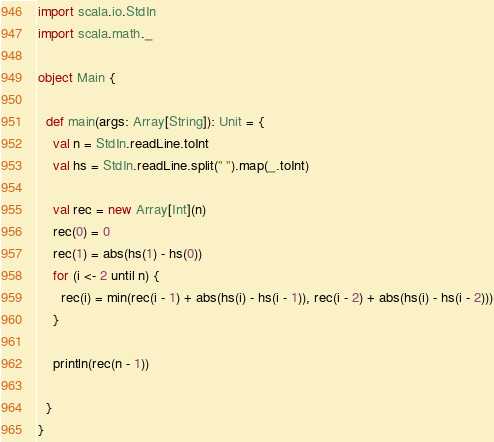Convert code to text. <code><loc_0><loc_0><loc_500><loc_500><_Scala_>import scala.io.StdIn
import scala.math._

object Main {

  def main(args: Array[String]): Unit = {
    val n = StdIn.readLine.toInt
    val hs = StdIn.readLine.split(" ").map(_.toInt)

    val rec = new Array[Int](n)
    rec(0) = 0
    rec(1) = abs(hs(1) - hs(0))
    for (i <- 2 until n) {
      rec(i) = min(rec(i - 1) + abs(hs(i) - hs(i - 1)), rec(i - 2) + abs(hs(i) - hs(i - 2)))
    }

    println(rec(n - 1))

  }
}</code> 